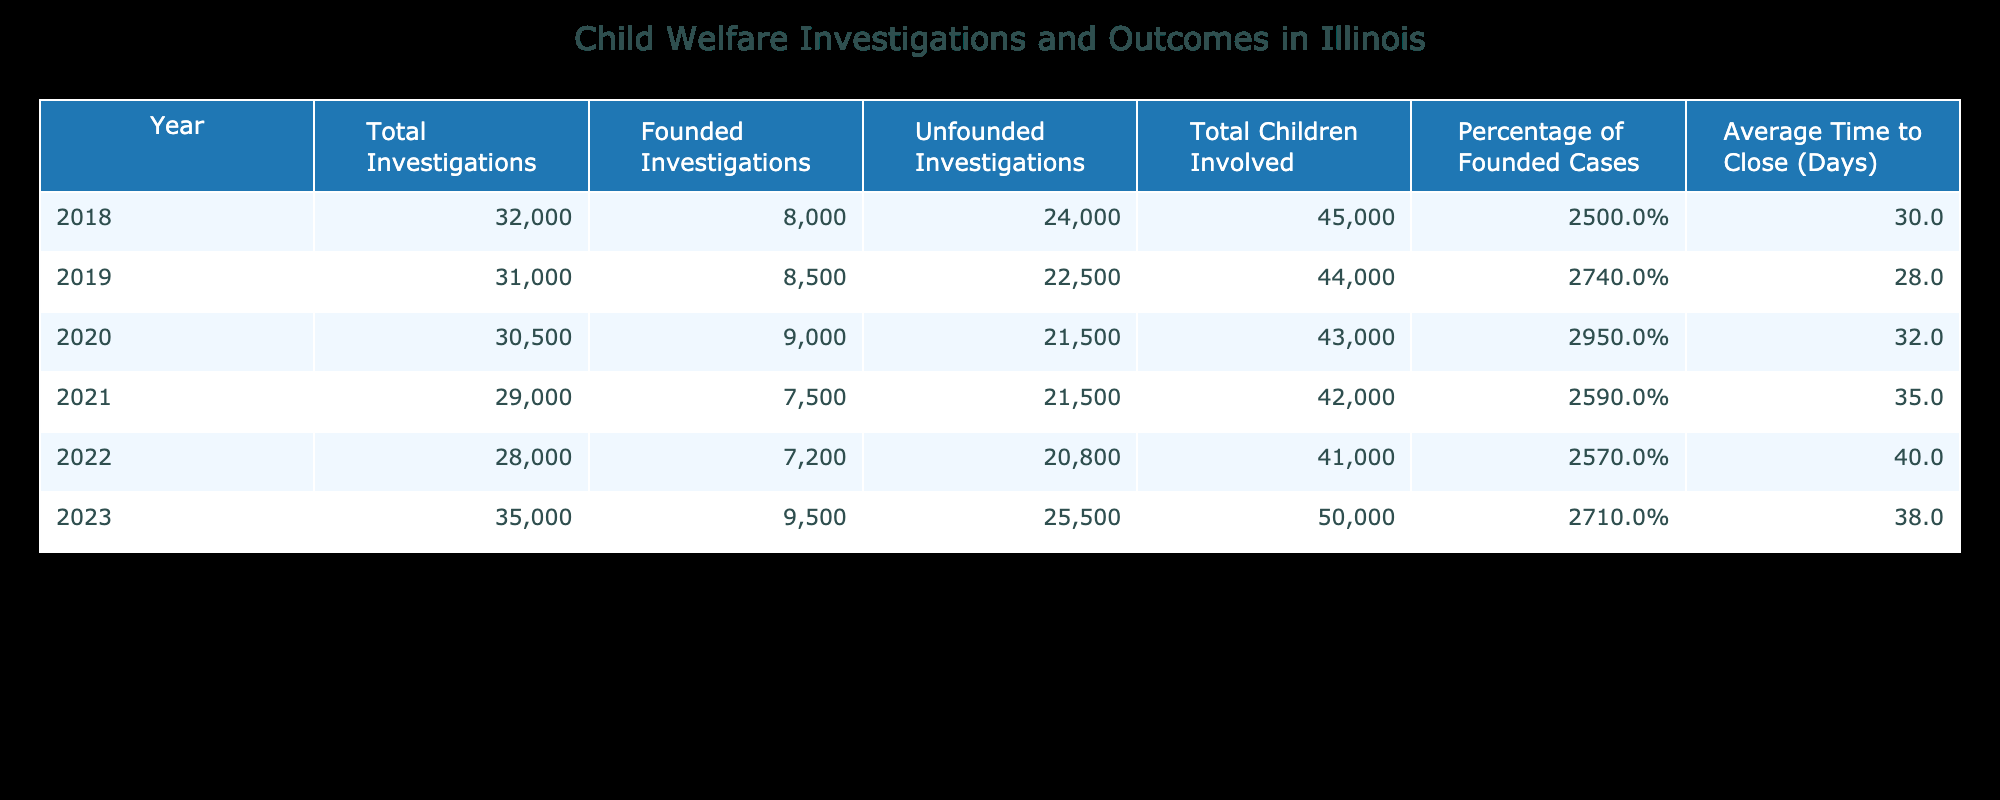What was the percentage of founded cases in 2020? The percentage of founded cases in 2020 is directly listed in the table under the relevant column. It shows as 29.5%.
Answer: 29.5% How many total investigations were conducted in 2022? Looking at the table, the total number of investigations in 2022 is specified in the "Total Investigations" column as 28,000.
Answer: 28000 What is the average time to close investigations in years 2019 and 2021 combined? The average time to close for 2019 is 28 days, and for 2021 it is 35 days. We calculate the average: (28 + 35) / 2 = 26.5.
Answer: 26.5 How many more unfounded investigations were there in 2023 compared to 2018? From the table, unfounded investigations in 2023 is 25,500 and in 2018 it is 24,000. The difference is 25,500 - 24,000 = 1,500.
Answer: 1500 Did the percentage of founded cases fall below 25% in any year from 2018 to 2022? The table shows the percentages of founded cases for 2018 (25.0%), 2019 (27.4%), 2020 (29.5%), 2021 (25.9%), and 2022 (25.7%). None of these percentages fell below 25%.
Answer: No Which year had the highest number of total children involved? Upon examining the "Total Children Involved" column, year 2023 had the highest number listed as 50,000.
Answer: 50000 What was the total number of founded investigations across all years? We sum the founded investigations from the table: 8,000 (2018) + 8,500 (2019) + 9,000 (2020) + 7,500 (2021) + 7,200 (2022) + 9,500 (2023) = 49,700.
Answer: 49700 Did the average time to close investigations increase from 2018 to 2023? In 2018, the time was 30 days, and in 2023, it was 38 days. Since 38 is greater than 30, it shows an increase.
Answer: Yes 